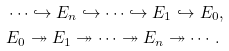<formula> <loc_0><loc_0><loc_500><loc_500>& \cdots \hookrightarrow E _ { n } \hookrightarrow \cdots \hookrightarrow E _ { 1 } \hookrightarrow E _ { 0 } , \\ & E _ { 0 } \twoheadrightarrow E _ { 1 } \twoheadrightarrow \cdots \twoheadrightarrow E _ { n } \twoheadrightarrow \cdots .</formula> 